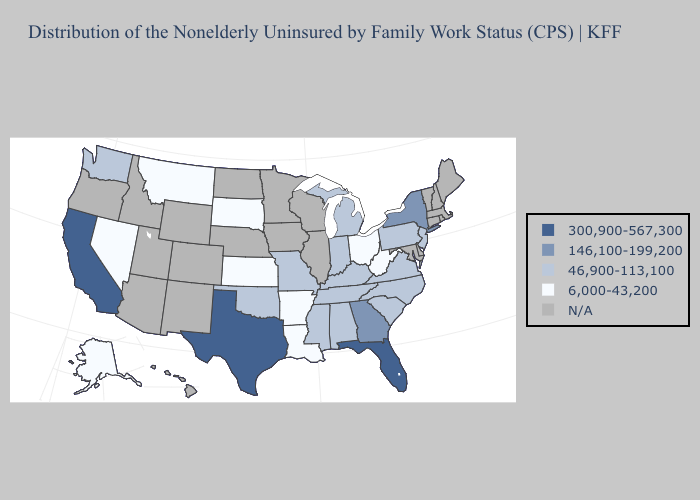Name the states that have a value in the range 6,000-43,200?
Write a very short answer. Alaska, Arkansas, Kansas, Louisiana, Montana, Nevada, Ohio, South Dakota, West Virginia. What is the lowest value in the Northeast?
Keep it brief. 46,900-113,100. Does the map have missing data?
Short answer required. Yes. Does Louisiana have the lowest value in the South?
Short answer required. Yes. Which states have the lowest value in the USA?
Write a very short answer. Alaska, Arkansas, Kansas, Louisiana, Montana, Nevada, Ohio, South Dakota, West Virginia. What is the value of Delaware?
Write a very short answer. N/A. What is the highest value in the USA?
Quick response, please. 300,900-567,300. What is the value of New Jersey?
Short answer required. 46,900-113,100. Name the states that have a value in the range 46,900-113,100?
Concise answer only. Alabama, Indiana, Kentucky, Michigan, Mississippi, Missouri, New Jersey, North Carolina, Oklahoma, Pennsylvania, South Carolina, Tennessee, Virginia, Washington. Which states have the highest value in the USA?
Give a very brief answer. California, Florida, Texas. Does the map have missing data?
Write a very short answer. Yes. What is the value of Georgia?
Be succinct. 146,100-199,200. Name the states that have a value in the range 6,000-43,200?
Write a very short answer. Alaska, Arkansas, Kansas, Louisiana, Montana, Nevada, Ohio, South Dakota, West Virginia. What is the value of Utah?
Be succinct. N/A. 